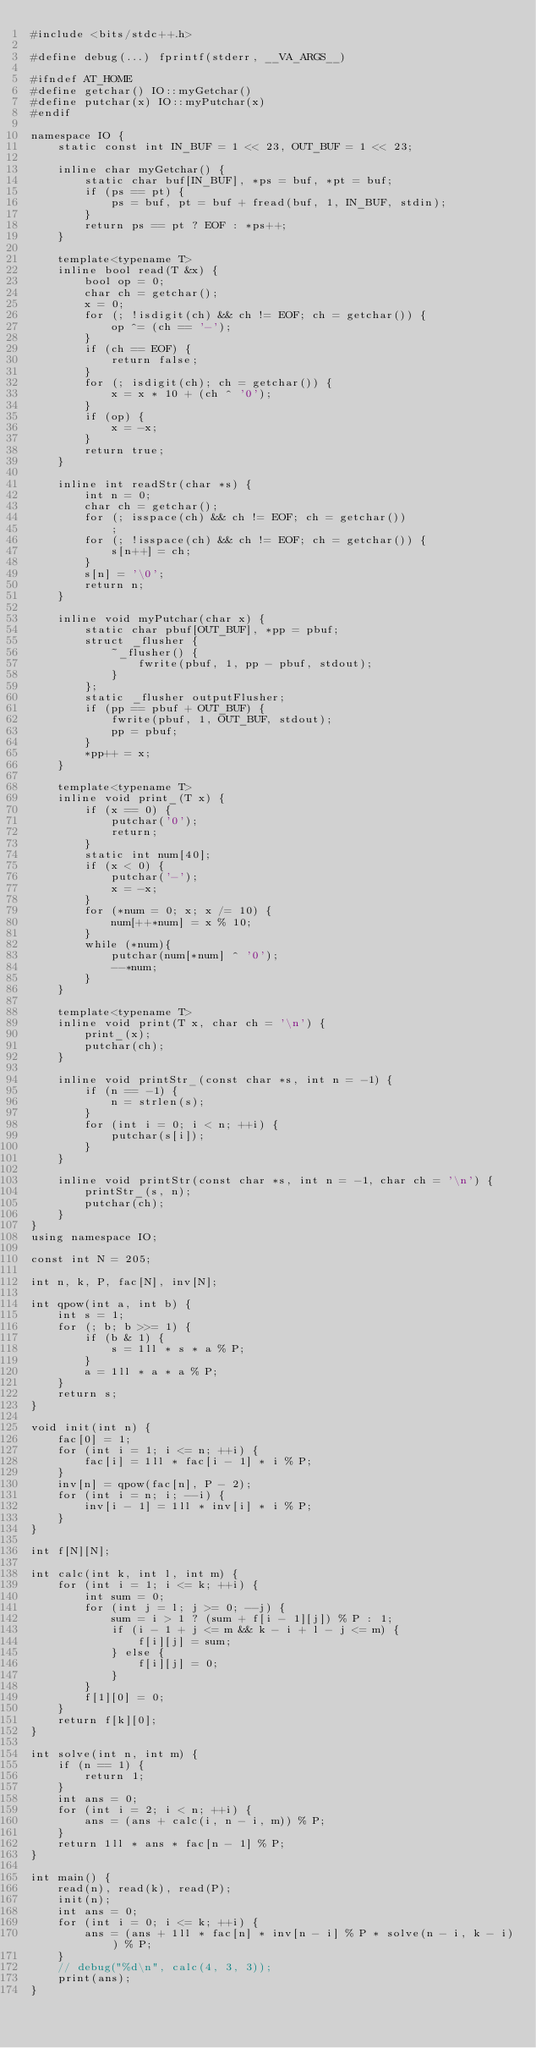<code> <loc_0><loc_0><loc_500><loc_500><_C++_>#include <bits/stdc++.h>

#define debug(...) fprintf(stderr, __VA_ARGS__)

#ifndef AT_HOME
#define getchar() IO::myGetchar()
#define putchar(x) IO::myPutchar(x)
#endif

namespace IO {
	static const int IN_BUF = 1 << 23, OUT_BUF = 1 << 23;

	inline char myGetchar() {
		static char buf[IN_BUF], *ps = buf, *pt = buf;
		if (ps == pt) {
			ps = buf, pt = buf + fread(buf, 1, IN_BUF, stdin);
		}
		return ps == pt ? EOF : *ps++;
	}

	template<typename T>
	inline bool read(T &x) {
		bool op = 0;
		char ch = getchar();
		x = 0;
		for (; !isdigit(ch) && ch != EOF; ch = getchar()) {
			op ^= (ch == '-');
		}
		if (ch == EOF) {
			return false;
		}
		for (; isdigit(ch); ch = getchar()) {
			x = x * 10 + (ch ^ '0');
		}
		if (op) {
			x = -x;
		}
		return true;
	}

	inline int readStr(char *s) {
		int n = 0;
		char ch = getchar();
		for (; isspace(ch) && ch != EOF; ch = getchar())
			;
		for (; !isspace(ch) && ch != EOF; ch = getchar()) {
			s[n++] = ch;
		}
		s[n] = '\0';
		return n;
	}

	inline void myPutchar(char x) {
		static char pbuf[OUT_BUF], *pp = pbuf;
		struct _flusher {
			~_flusher() {
				fwrite(pbuf, 1, pp - pbuf, stdout);
			}
		};
		static _flusher outputFlusher;
		if (pp == pbuf + OUT_BUF) {
			fwrite(pbuf, 1, OUT_BUF, stdout);
			pp = pbuf;
		}
		*pp++ = x;
	}

	template<typename T>
	inline void print_(T x) {
		if (x == 0) {
			putchar('0');
			return;
		}
		static int num[40];
		if (x < 0) {
			putchar('-');
			x = -x;
		}
		for (*num = 0; x; x /= 10) {
			num[++*num] = x % 10;
		}
		while (*num){
			putchar(num[*num] ^ '0');
			--*num;
		}
	}

	template<typename T>
	inline void print(T x, char ch = '\n') {
		print_(x);
		putchar(ch);
	}

	inline void printStr_(const char *s, int n = -1) {
		if (n == -1) {
			n = strlen(s);
		}
		for (int i = 0; i < n; ++i) {
			putchar(s[i]);
		}
	}

	inline void printStr(const char *s, int n = -1, char ch = '\n') {
		printStr_(s, n);
		putchar(ch);
	}
}
using namespace IO;

const int N = 205;

int n, k, P, fac[N], inv[N];

int qpow(int a, int b) {
	int s = 1;
	for (; b; b >>= 1) {
		if (b & 1) {
			s = 1ll * s * a % P;
		}
		a = 1ll * a * a % P;
	}
	return s;
}

void init(int n) {
	fac[0] = 1;
	for (int i = 1; i <= n; ++i) {
		fac[i] = 1ll * fac[i - 1] * i % P;
	}
	inv[n] = qpow(fac[n], P - 2);
	for (int i = n; i; --i) {
		inv[i - 1] = 1ll * inv[i] * i % P;
	}
}

int f[N][N];

int calc(int k, int l, int m) {
	for (int i = 1; i <= k; ++i) {
		int sum = 0;
		for (int j = l; j >= 0; --j) {
			sum = i > 1 ? (sum + f[i - 1][j]) % P : 1;
			if (i - 1 + j <= m && k - i + l - j <= m) {
				f[i][j] = sum;
			} else {
				f[i][j] = 0;
			}
		}
		f[1][0] = 0;
	}
	return f[k][0];
}

int solve(int n, int m) {
	if (n == 1) {
		return 1;
	}
	int ans = 0;
	for (int i = 2; i < n; ++i) {
		ans = (ans + calc(i, n - i, m)) % P;
	}
	return 1ll * ans * fac[n - 1] % P;
}

int main() {
	read(n), read(k), read(P);
	init(n);
	int ans = 0;
	for (int i = 0; i <= k; ++i) {
		ans = (ans + 1ll * fac[n] * inv[n - i] % P * solve(n - i, k - i)) % P;
	}
	// debug("%d\n", calc(4, 3, 3));
	print(ans);
}
</code> 